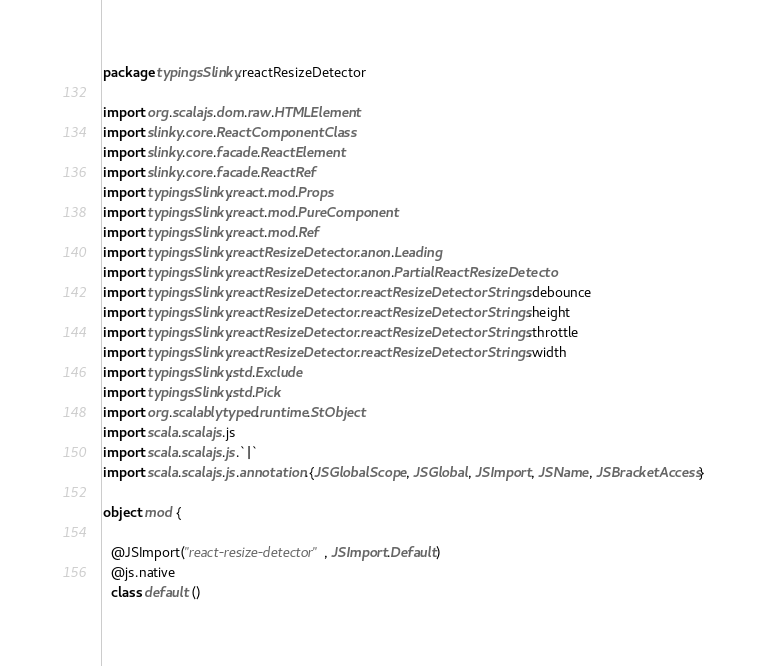<code> <loc_0><loc_0><loc_500><loc_500><_Scala_>package typingsSlinky.reactResizeDetector

import org.scalajs.dom.raw.HTMLElement
import slinky.core.ReactComponentClass
import slinky.core.facade.ReactElement
import slinky.core.facade.ReactRef
import typingsSlinky.react.mod.Props
import typingsSlinky.react.mod.PureComponent
import typingsSlinky.react.mod.Ref
import typingsSlinky.reactResizeDetector.anon.Leading
import typingsSlinky.reactResizeDetector.anon.PartialReactResizeDetecto
import typingsSlinky.reactResizeDetector.reactResizeDetectorStrings.debounce
import typingsSlinky.reactResizeDetector.reactResizeDetectorStrings.height
import typingsSlinky.reactResizeDetector.reactResizeDetectorStrings.throttle
import typingsSlinky.reactResizeDetector.reactResizeDetectorStrings.width
import typingsSlinky.std.Exclude
import typingsSlinky.std.Pick
import org.scalablytyped.runtime.StObject
import scala.scalajs.js
import scala.scalajs.js.`|`
import scala.scalajs.js.annotation.{JSGlobalScope, JSGlobal, JSImport, JSName, JSBracketAccess}

object mod {
  
  @JSImport("react-resize-detector", JSImport.Default)
  @js.native
  class default ()</code> 